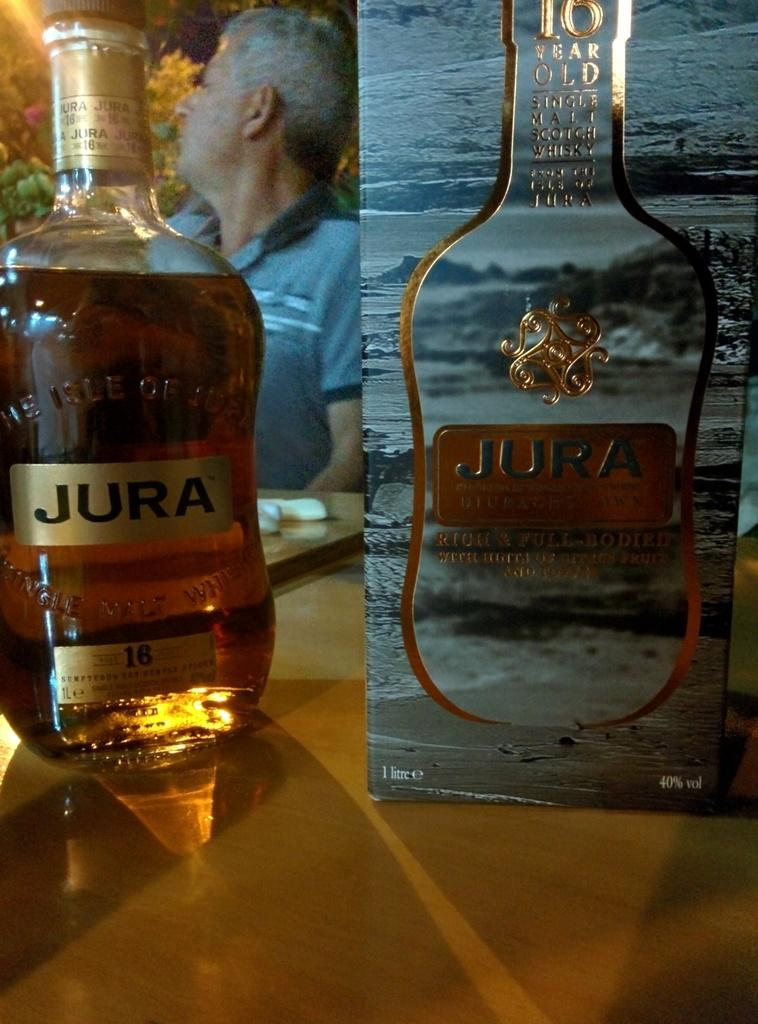<image>
Provide a brief description of the given image. Bottle of JURA alcohol next to the box. 